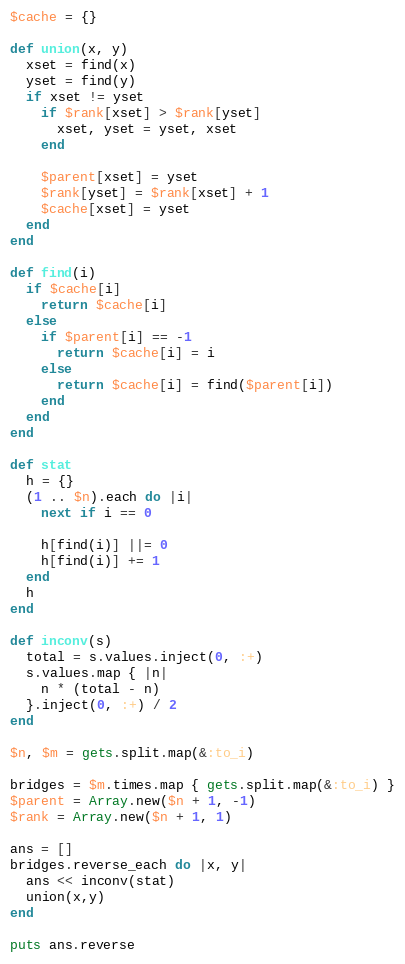<code> <loc_0><loc_0><loc_500><loc_500><_Ruby_>$cache = {}

def union(x, y)
  xset = find(x)
  yset = find(y)
  if xset != yset
    if $rank[xset] > $rank[yset]
      xset, yset = yset, xset
    end
      
    $parent[xset] = yset
    $rank[yset] = $rank[xset] + 1
    $cache[xset] = yset
  end
end

def find(i)
  if $cache[i]
    return $cache[i]
  else
    if $parent[i] == -1
      return $cache[i] = i
    else
      return $cache[i] = find($parent[i])
    end
  end
end

def stat
  h = {}
  (1 .. $n).each do |i|
    next if i == 0

    h[find(i)] ||= 0
    h[find(i)] += 1
  end
  h
end

def inconv(s)
  total = s.values.inject(0, :+)
  s.values.map { |n|
    n * (total - n)
  }.inject(0, :+) / 2
end

$n, $m = gets.split.map(&:to_i)

bridges = $m.times.map { gets.split.map(&:to_i) }
$parent = Array.new($n + 1, -1)
$rank = Array.new($n + 1, 1)

ans = []
bridges.reverse_each do |x, y|
  ans << inconv(stat)
  union(x,y)
end

puts ans.reverse
</code> 